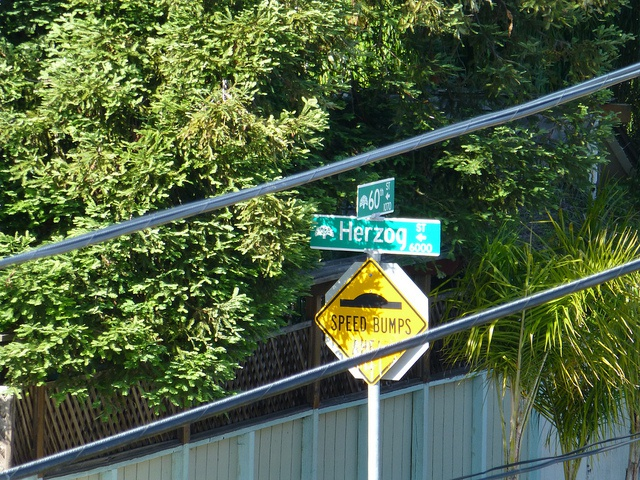Describe the objects in this image and their specific colors. I can see various objects in this image with different colors. 